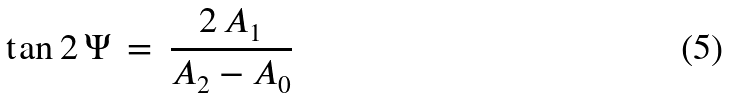Convert formula to latex. <formula><loc_0><loc_0><loc_500><loc_500>\tan 2 \, \Psi \, = \, \frac { 2 \, A _ { 1 } } { A _ { 2 } - A _ { 0 } }</formula> 